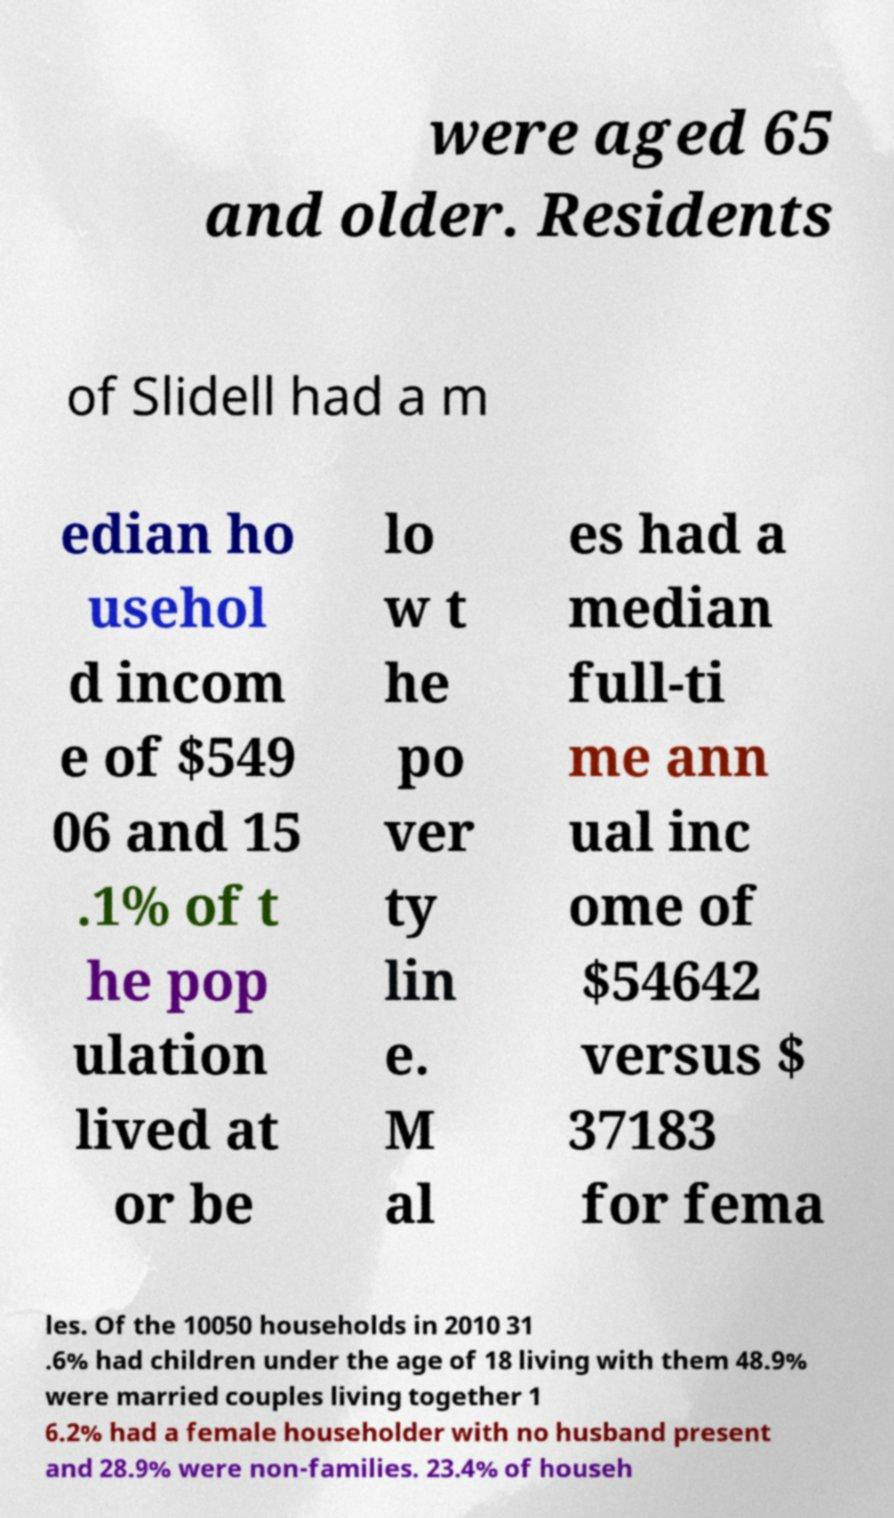I need the written content from this picture converted into text. Can you do that? were aged 65 and older. Residents of Slidell had a m edian ho usehol d incom e of $549 06 and 15 .1% of t he pop ulation lived at or be lo w t he po ver ty lin e. M al es had a median full-ti me ann ual inc ome of $54642 versus $ 37183 for fema les. Of the 10050 households in 2010 31 .6% had children under the age of 18 living with them 48.9% were married couples living together 1 6.2% had a female householder with no husband present and 28.9% were non-families. 23.4% of househ 